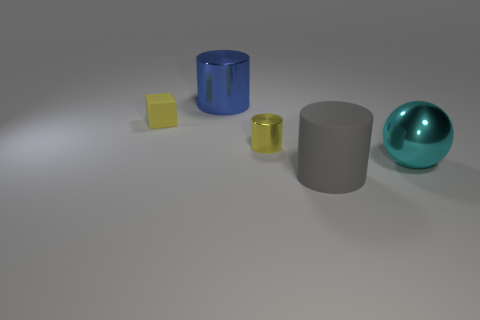Subtract all large gray rubber cylinders. How many cylinders are left? 2 Add 4 large red rubber things. How many objects exist? 9 Subtract 1 blocks. How many blocks are left? 0 Subtract all cubes. How many objects are left? 4 Subtract all blue cylinders. How many cylinders are left? 2 Subtract all gray spheres. How many gray cylinders are left? 1 Subtract all small yellow metallic objects. Subtract all metal objects. How many objects are left? 1 Add 3 yellow shiny objects. How many yellow shiny objects are left? 4 Add 2 yellow cylinders. How many yellow cylinders exist? 3 Subtract 0 green cubes. How many objects are left? 5 